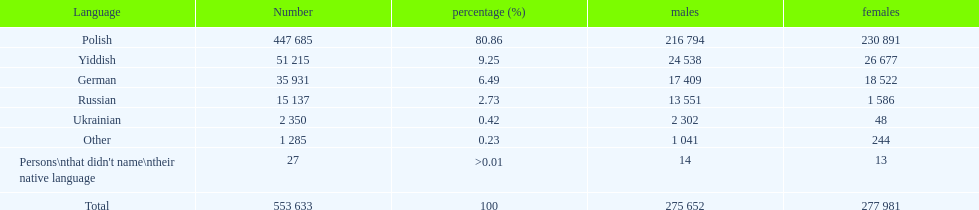How many individuals refrained from stating their native language? 27. 